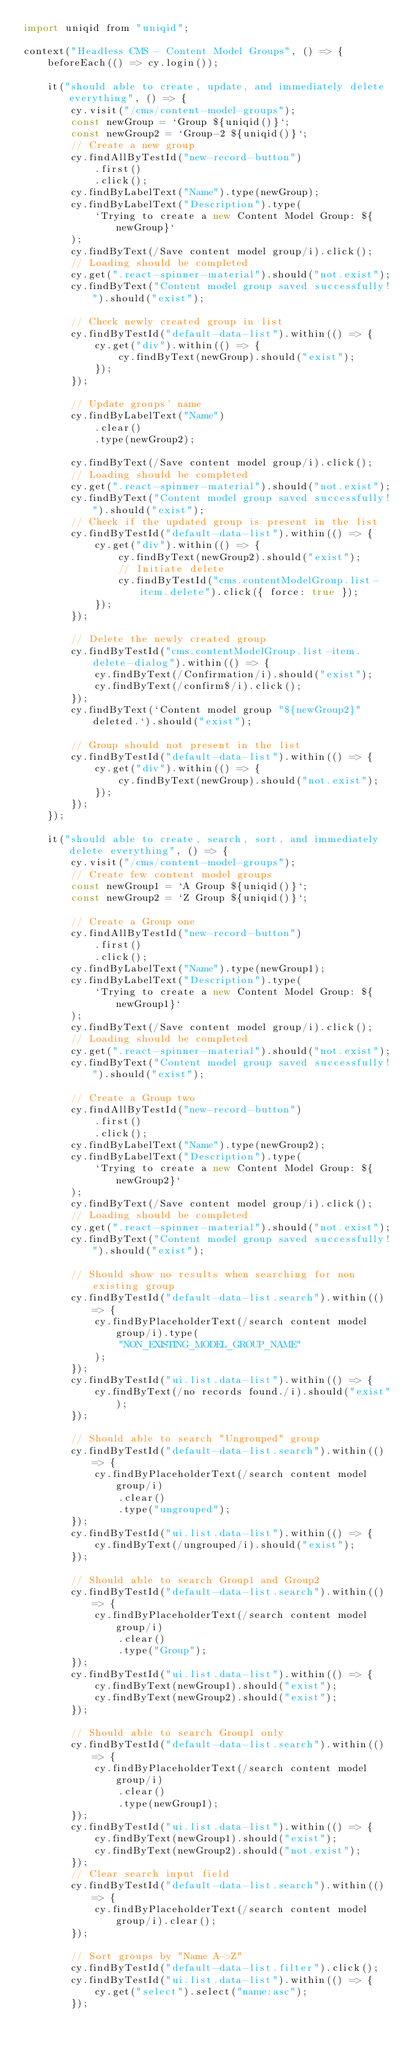Convert code to text. <code><loc_0><loc_0><loc_500><loc_500><_JavaScript_>import uniqid from "uniqid";

context("Headless CMS - Content Model Groups", () => {
    beforeEach(() => cy.login());

    it("should able to create, update, and immediately delete everything", () => {
        cy.visit("/cms/content-model-groups");
        const newGroup = `Group ${uniqid()}`;
        const newGroup2 = `Group-2 ${uniqid()}`;
        // Create a new group
        cy.findAllByTestId("new-record-button")
            .first()
            .click();
        cy.findByLabelText("Name").type(newGroup);
        cy.findByLabelText("Description").type(
            `Trying to create a new Content Model Group: ${newGroup}`
        );
        cy.findByText(/Save content model group/i).click();
        // Loading should be completed
        cy.get(".react-spinner-material").should("not.exist");
        cy.findByText("Content model group saved successfully!").should("exist");

        // Check newly created group in list
        cy.findByTestId("default-data-list").within(() => {
            cy.get("div").within(() => {
                cy.findByText(newGroup).should("exist");
            });
        });

        // Update groups' name
        cy.findByLabelText("Name")
            .clear()
            .type(newGroup2);

        cy.findByText(/Save content model group/i).click();
        // Loading should be completed
        cy.get(".react-spinner-material").should("not.exist");
        cy.findByText("Content model group saved successfully!").should("exist");
        // Check if the updated group is present in the list
        cy.findByTestId("default-data-list").within(() => {
            cy.get("div").within(() => {
                cy.findByText(newGroup2).should("exist");
                // Initiate delete
                cy.findByTestId("cms.contentModelGroup.list-item.delete").click({ force: true });
            });
        });

        // Delete the newly created group
        cy.findByTestId("cms.contentModelGroup.list-item.delete-dialog").within(() => {
            cy.findByText(/Confirmation/i).should("exist");
            cy.findByText(/confirm$/i).click();
        });
        cy.findByText(`Content model group "${newGroup2}" deleted.`).should("exist");

        // Group should not present in the list
        cy.findByTestId("default-data-list").within(() => {
            cy.get("div").within(() => {
                cy.findByText(newGroup).should("not.exist");
            });
        });
    });

    it("should able to create, search, sort, and immediately delete everything", () => {
        cy.visit("/cms/content-model-groups");
        // Create few content model groups
        const newGroup1 = `A Group ${uniqid()}`;
        const newGroup2 = `Z Group ${uniqid()}`;

        // Create a Group one
        cy.findAllByTestId("new-record-button")
            .first()
            .click();
        cy.findByLabelText("Name").type(newGroup1);
        cy.findByLabelText("Description").type(
            `Trying to create a new Content Model Group: ${newGroup1}`
        );
        cy.findByText(/Save content model group/i).click();
        // Loading should be completed
        cy.get(".react-spinner-material").should("not.exist");
        cy.findByText("Content model group saved successfully!").should("exist");

        // Create a Group two
        cy.findAllByTestId("new-record-button")
            .first()
            .click();
        cy.findByLabelText("Name").type(newGroup2);
        cy.findByLabelText("Description").type(
            `Trying to create a new Content Model Group: ${newGroup2}`
        );
        cy.findByText(/Save content model group/i).click();
        // Loading should be completed
        cy.get(".react-spinner-material").should("not.exist");
        cy.findByText("Content model group saved successfully!").should("exist");

        // Should show no results when searching for non existing group
        cy.findByTestId("default-data-list.search").within(() => {
            cy.findByPlaceholderText(/search content model group/i).type(
                "NON_EXISTING_MODEL_GROUP_NAME"
            );
        });
        cy.findByTestId("ui.list.data-list").within(() => {
            cy.findByText(/no records found./i).should("exist");
        });

        // Should able to search "Ungrouped" group
        cy.findByTestId("default-data-list.search").within(() => {
            cy.findByPlaceholderText(/search content model group/i)
                .clear()
                .type("ungrouped");
        });
        cy.findByTestId("ui.list.data-list").within(() => {
            cy.findByText(/ungrouped/i).should("exist");
        });

        // Should able to search Group1 and Group2
        cy.findByTestId("default-data-list.search").within(() => {
            cy.findByPlaceholderText(/search content model group/i)
                .clear()
                .type("Group");
        });
        cy.findByTestId("ui.list.data-list").within(() => {
            cy.findByText(newGroup1).should("exist");
            cy.findByText(newGroup2).should("exist");
        });

        // Should able to search Group1 only
        cy.findByTestId("default-data-list.search").within(() => {
            cy.findByPlaceholderText(/search content model group/i)
                .clear()
                .type(newGroup1);
        });
        cy.findByTestId("ui.list.data-list").within(() => {
            cy.findByText(newGroup1).should("exist");
            cy.findByText(newGroup2).should("not.exist");
        });
        // Clear search input field
        cy.findByTestId("default-data-list.search").within(() => {
            cy.findByPlaceholderText(/search content model group/i).clear();
        });

        // Sort groups by "Name A->Z"
        cy.findByTestId("default-data-list.filter").click();
        cy.findByTestId("ui.list.data-list").within(() => {
            cy.get("select").select("name:asc");
        });</code> 